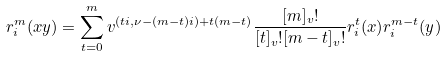<formula> <loc_0><loc_0><loc_500><loc_500>{ r ^ { m } _ { i } } ( x y ) = \sum _ { t = 0 } ^ { m } v ^ { ( t i , \nu - ( m - t ) i ) + t ( m - t ) } \frac { [ m ] _ { v } ! } { [ t ] _ { v } ! [ m - t ] _ { v } ! } { r _ { i } ^ { t } } ( x ) { r _ { i } ^ { m - t } } ( y )</formula> 